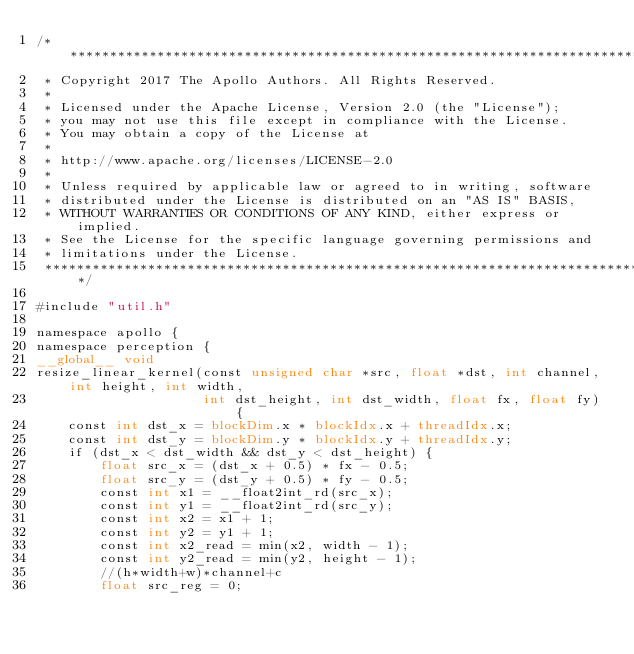Convert code to text. <code><loc_0><loc_0><loc_500><loc_500><_Cuda_>/******************************************************************************
 * Copyright 2017 The Apollo Authors. All Rights Reserved.
 *
 * Licensed under the Apache License, Version 2.0 (the "License");
 * you may not use this file except in compliance with the License.
 * You may obtain a copy of the License at
 *
 * http://www.apache.org/licenses/LICENSE-2.0
 *
 * Unless required by applicable law or agreed to in writing, software
 * distributed under the License is distributed on an "AS IS" BASIS,
 * WITHOUT WARRANTIES OR CONDITIONS OF ANY KIND, either express or implied.
 * See the License for the specific language governing permissions and
 * limitations under the License.
 *****************************************************************************/

#include "util.h"

namespace apollo {
namespace perception {
__global__ void
resize_linear_kernel(const unsigned char *src, float *dst, int channel, int height, int width,
                     int dst_height, int dst_width, float fx, float fy) {
    const int dst_x = blockDim.x * blockIdx.x + threadIdx.x;
    const int dst_y = blockDim.y * blockIdx.y + threadIdx.y;
    if (dst_x < dst_width && dst_y < dst_height) {
        float src_x = (dst_x + 0.5) * fx - 0.5;
        float src_y = (dst_y + 0.5) * fy - 0.5;
        const int x1 = __float2int_rd(src_x);
        const int y1 = __float2int_rd(src_y);
        const int x2 = x1 + 1;
        const int y2 = y1 + 1;
        const int x2_read = min(x2, width - 1);
        const int y2_read = min(y2, height - 1);
        //(h*width+w)*channel+c
        float src_reg = 0;</code> 